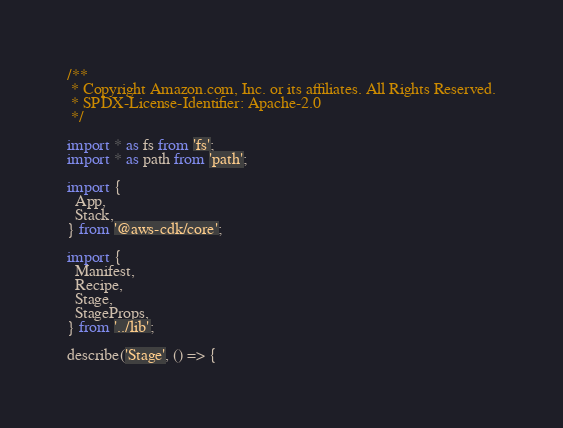Convert code to text. <code><loc_0><loc_0><loc_500><loc_500><_TypeScript_>/**
 * Copyright Amazon.com, Inc. or its affiliates. All Rights Reserved.
 * SPDX-License-Identifier: Apache-2.0
 */

import * as fs from 'fs';
import * as path from 'path';

import {
  App,
  Stack,
} from '@aws-cdk/core';

import {
  Manifest,
  Recipe,
  Stage,
  StageProps,
} from '../lib';

describe('Stage', () => {</code> 